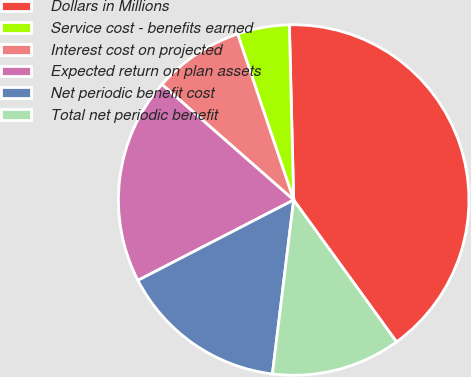Convert chart to OTSL. <chart><loc_0><loc_0><loc_500><loc_500><pie_chart><fcel>Dollars in Millions<fcel>Service cost - benefits earned<fcel>Interest cost on projected<fcel>Expected return on plan assets<fcel>Net periodic benefit cost<fcel>Total net periodic benefit<nl><fcel>40.41%<fcel>4.79%<fcel>8.36%<fcel>19.04%<fcel>15.48%<fcel>11.92%<nl></chart> 